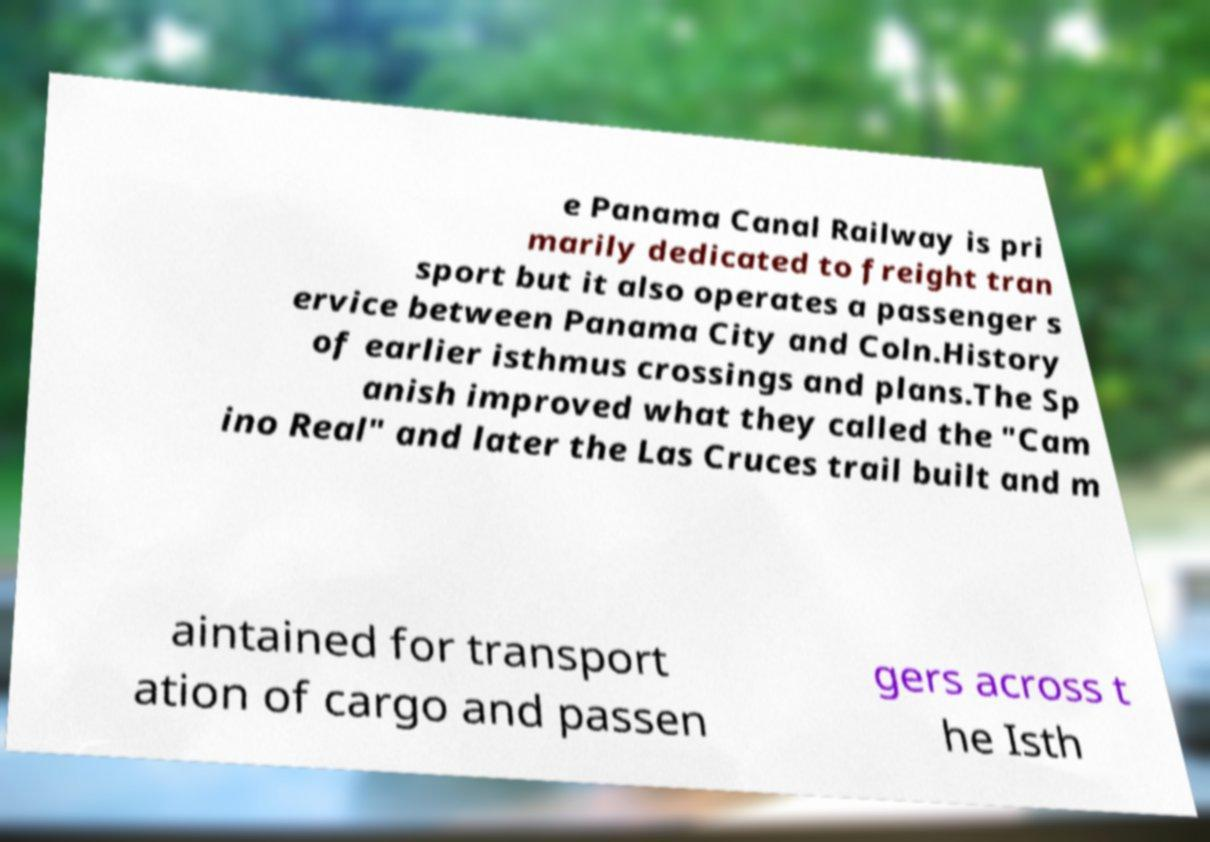Can you accurately transcribe the text from the provided image for me? e Panama Canal Railway is pri marily dedicated to freight tran sport but it also operates a passenger s ervice between Panama City and Coln.History of earlier isthmus crossings and plans.The Sp anish improved what they called the "Cam ino Real" and later the Las Cruces trail built and m aintained for transport ation of cargo and passen gers across t he Isth 